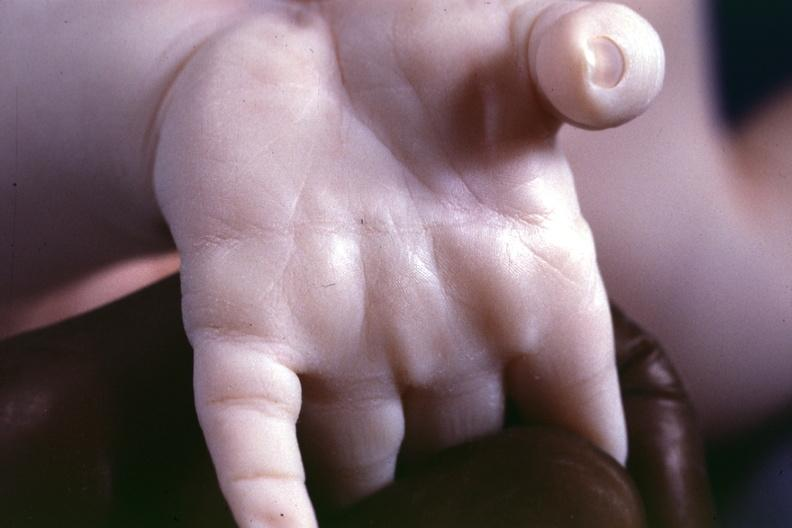s simian crease present?
Answer the question using a single word or phrase. Yes 